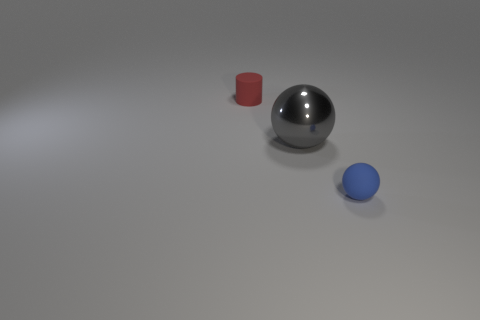Add 1 blue things. How many objects exist? 4 Subtract all cylinders. How many objects are left? 2 Add 2 tiny objects. How many tiny objects are left? 4 Add 3 small spheres. How many small spheres exist? 4 Subtract 0 brown cubes. How many objects are left? 3 Subtract all large gray balls. Subtract all blue matte objects. How many objects are left? 1 